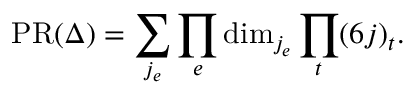<formula> <loc_0><loc_0><loc_500><loc_500>P R ( \Delta ) = \sum _ { j _ { e } } \prod _ { e } d i m _ { j _ { e } } \prod _ { t } ( 6 j ) _ { t } .</formula> 